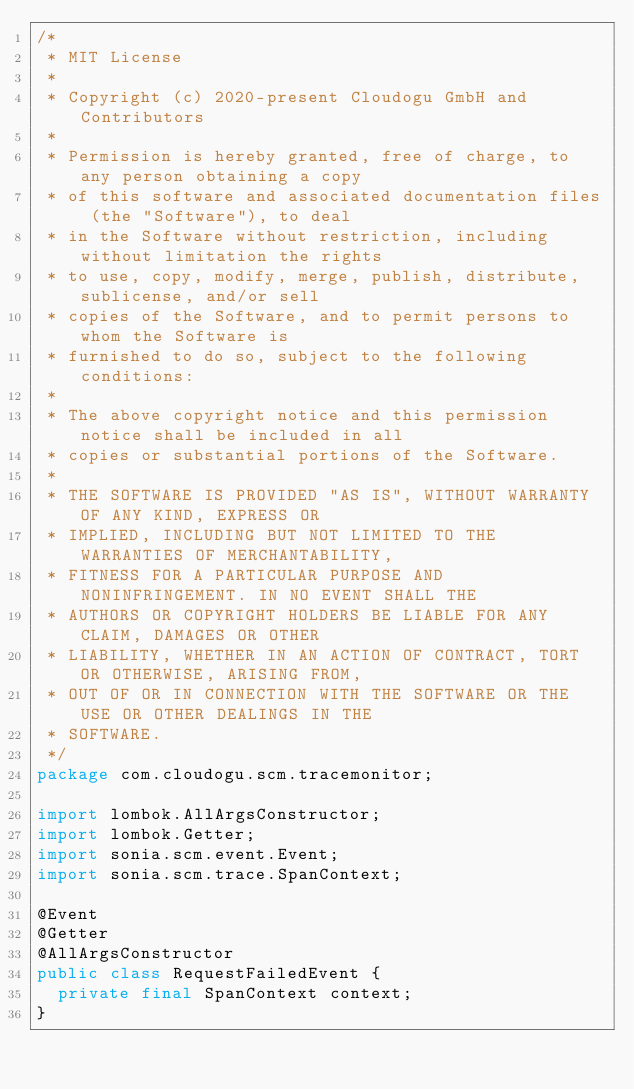Convert code to text. <code><loc_0><loc_0><loc_500><loc_500><_Java_>/*
 * MIT License
 *
 * Copyright (c) 2020-present Cloudogu GmbH and Contributors
 *
 * Permission is hereby granted, free of charge, to any person obtaining a copy
 * of this software and associated documentation files (the "Software"), to deal
 * in the Software without restriction, including without limitation the rights
 * to use, copy, modify, merge, publish, distribute, sublicense, and/or sell
 * copies of the Software, and to permit persons to whom the Software is
 * furnished to do so, subject to the following conditions:
 *
 * The above copyright notice and this permission notice shall be included in all
 * copies or substantial portions of the Software.
 *
 * THE SOFTWARE IS PROVIDED "AS IS", WITHOUT WARRANTY OF ANY KIND, EXPRESS OR
 * IMPLIED, INCLUDING BUT NOT LIMITED TO THE WARRANTIES OF MERCHANTABILITY,
 * FITNESS FOR A PARTICULAR PURPOSE AND NONINFRINGEMENT. IN NO EVENT SHALL THE
 * AUTHORS OR COPYRIGHT HOLDERS BE LIABLE FOR ANY CLAIM, DAMAGES OR OTHER
 * LIABILITY, WHETHER IN AN ACTION OF CONTRACT, TORT OR OTHERWISE, ARISING FROM,
 * OUT OF OR IN CONNECTION WITH THE SOFTWARE OR THE USE OR OTHER DEALINGS IN THE
 * SOFTWARE.
 */
package com.cloudogu.scm.tracemonitor;

import lombok.AllArgsConstructor;
import lombok.Getter;
import sonia.scm.event.Event;
import sonia.scm.trace.SpanContext;

@Event
@Getter
@AllArgsConstructor
public class RequestFailedEvent {
  private final SpanContext context;
}
</code> 